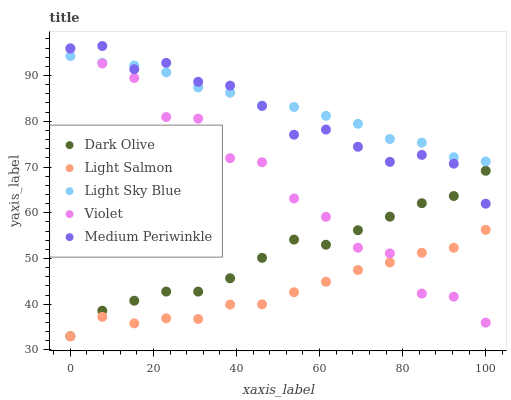Does Light Salmon have the minimum area under the curve?
Answer yes or no. Yes. Does Light Sky Blue have the maximum area under the curve?
Answer yes or no. Yes. Does Dark Olive have the minimum area under the curve?
Answer yes or no. No. Does Dark Olive have the maximum area under the curve?
Answer yes or no. No. Is Light Sky Blue the smoothest?
Answer yes or no. Yes. Is Violet the roughest?
Answer yes or no. Yes. Is Dark Olive the smoothest?
Answer yes or no. No. Is Dark Olive the roughest?
Answer yes or no. No. Does Light Salmon have the lowest value?
Answer yes or no. Yes. Does Medium Periwinkle have the lowest value?
Answer yes or no. No. Does Medium Periwinkle have the highest value?
Answer yes or no. Yes. Does Dark Olive have the highest value?
Answer yes or no. No. Is Light Salmon less than Light Sky Blue?
Answer yes or no. Yes. Is Light Sky Blue greater than Dark Olive?
Answer yes or no. Yes. Does Medium Periwinkle intersect Dark Olive?
Answer yes or no. Yes. Is Medium Periwinkle less than Dark Olive?
Answer yes or no. No. Is Medium Periwinkle greater than Dark Olive?
Answer yes or no. No. Does Light Salmon intersect Light Sky Blue?
Answer yes or no. No. 